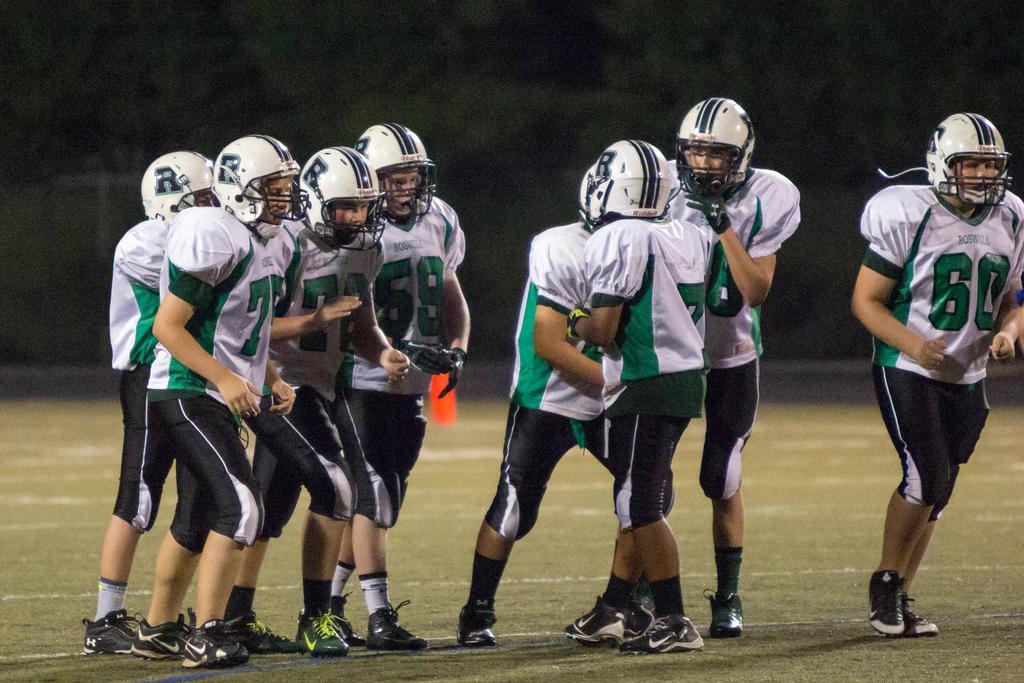Describe this image in one or two sentences. In this image there are a few people standing on the ground. They are wearing jersey and helmets. There is the grass on the ground. The background is dark. 